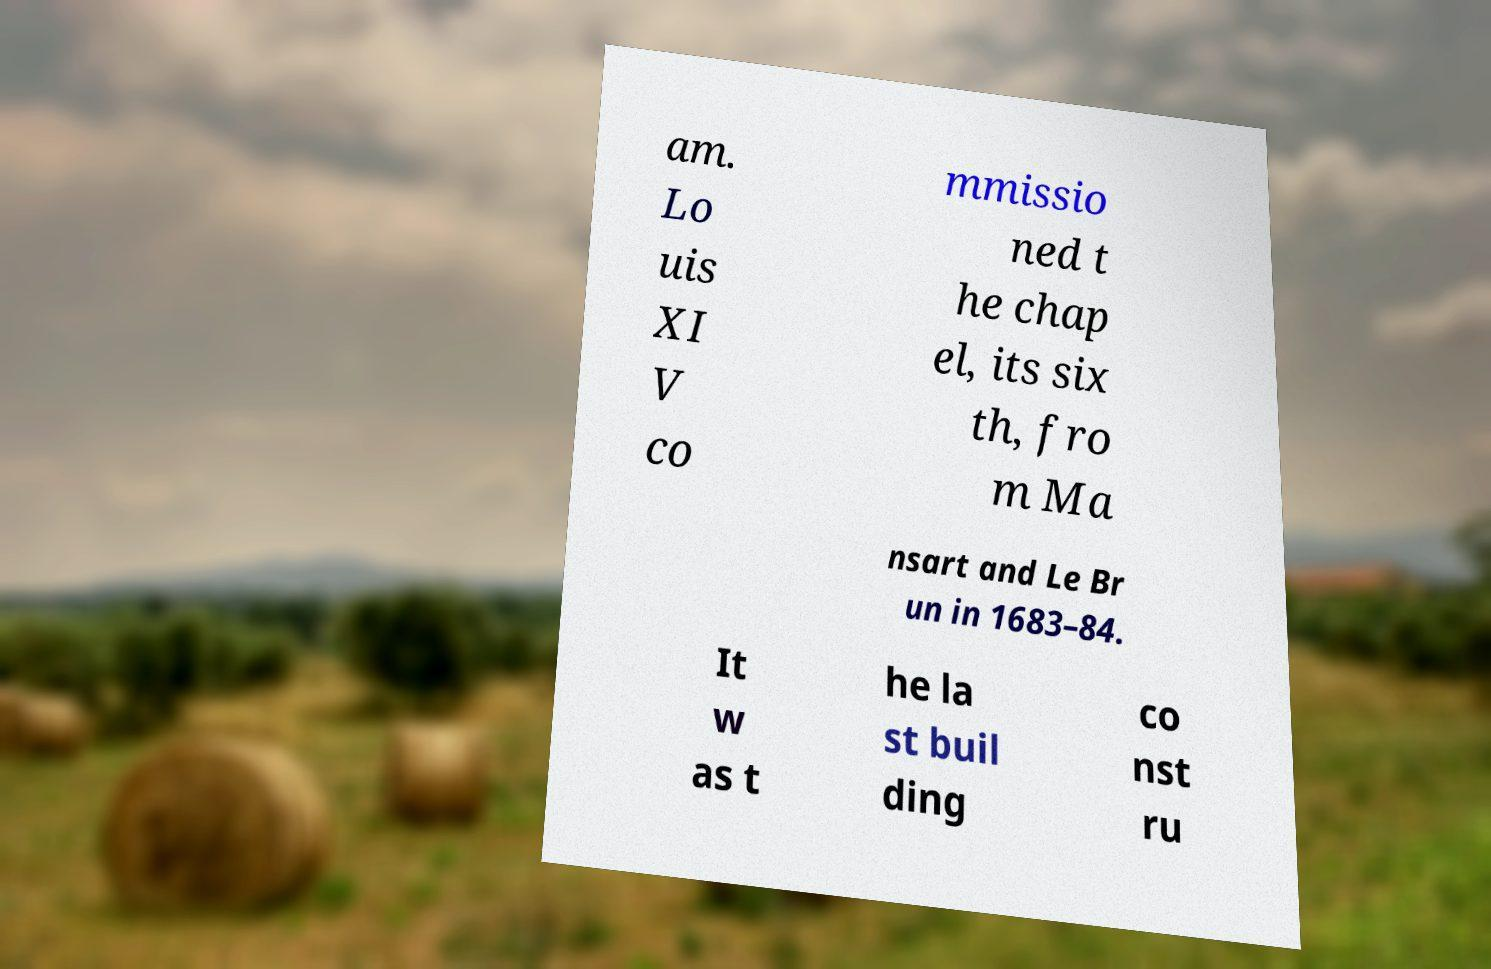Please identify and transcribe the text found in this image. am. Lo uis XI V co mmissio ned t he chap el, its six th, fro m Ma nsart and Le Br un in 1683–84. It w as t he la st buil ding co nst ru 